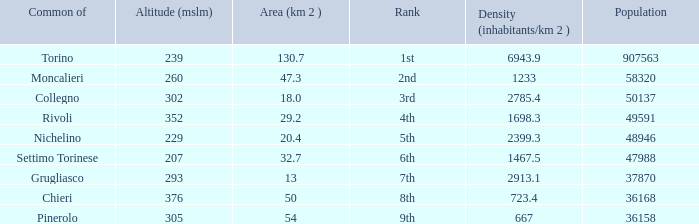The common of Chieri has what population density? 723.4. 